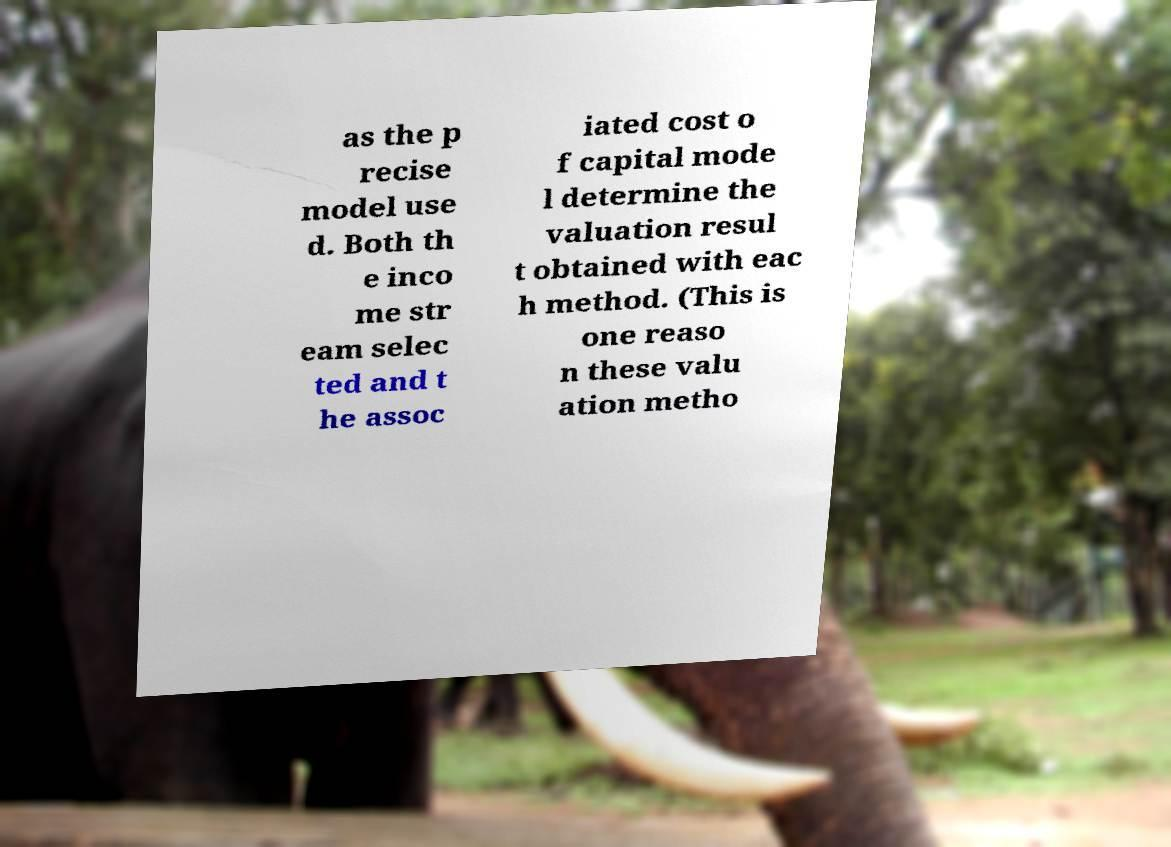I need the written content from this picture converted into text. Can you do that? as the p recise model use d. Both th e inco me str eam selec ted and t he assoc iated cost o f capital mode l determine the valuation resul t obtained with eac h method. (This is one reaso n these valu ation metho 